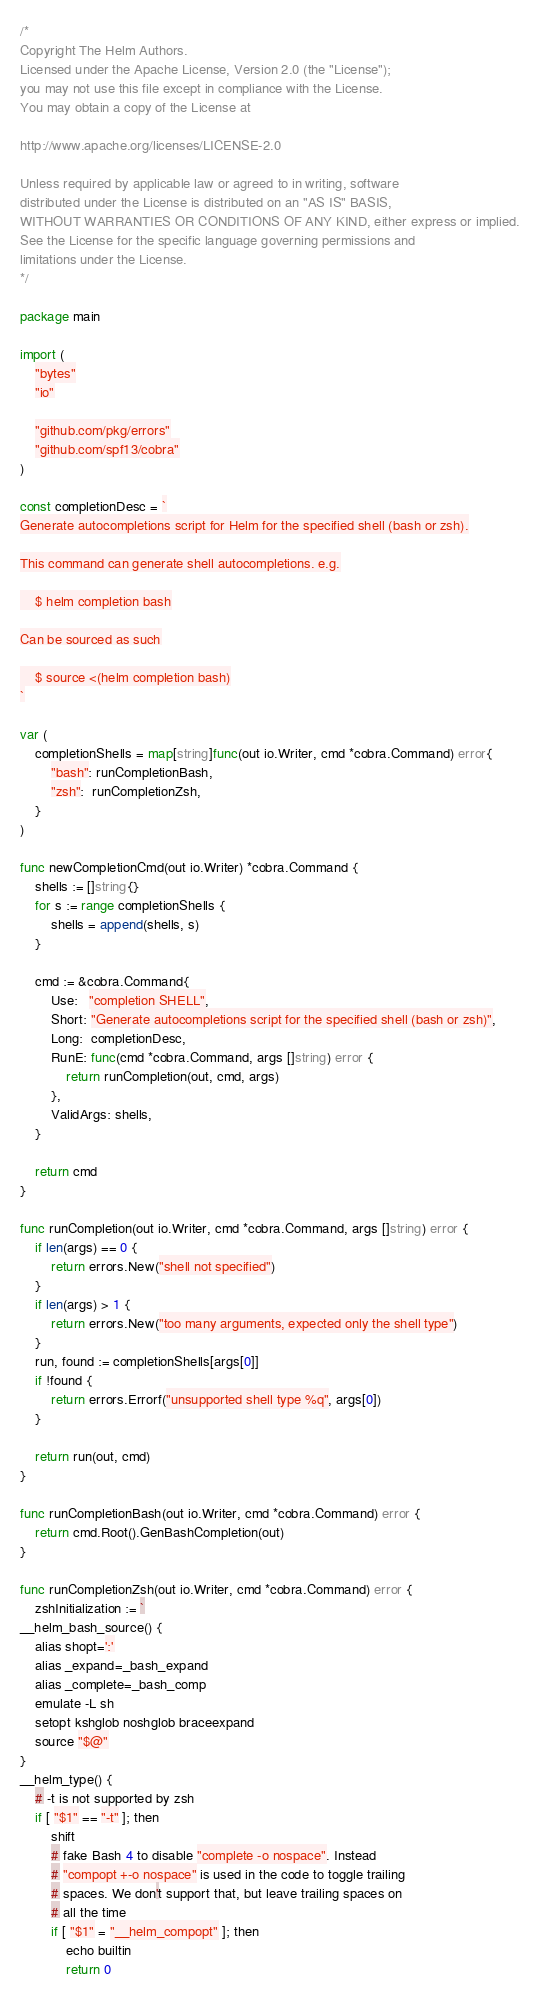Convert code to text. <code><loc_0><loc_0><loc_500><loc_500><_Go_>/*
Copyright The Helm Authors.
Licensed under the Apache License, Version 2.0 (the "License");
you may not use this file except in compliance with the License.
You may obtain a copy of the License at

http://www.apache.org/licenses/LICENSE-2.0

Unless required by applicable law or agreed to in writing, software
distributed under the License is distributed on an "AS IS" BASIS,
WITHOUT WARRANTIES OR CONDITIONS OF ANY KIND, either express or implied.
See the License for the specific language governing permissions and
limitations under the License.
*/

package main

import (
	"bytes"
	"io"

	"github.com/pkg/errors"
	"github.com/spf13/cobra"
)

const completionDesc = `
Generate autocompletions script for Helm for the specified shell (bash or zsh).

This command can generate shell autocompletions. e.g.

	$ helm completion bash

Can be sourced as such

	$ source <(helm completion bash)
`

var (
	completionShells = map[string]func(out io.Writer, cmd *cobra.Command) error{
		"bash": runCompletionBash,
		"zsh":  runCompletionZsh,
	}
)

func newCompletionCmd(out io.Writer) *cobra.Command {
	shells := []string{}
	for s := range completionShells {
		shells = append(shells, s)
	}

	cmd := &cobra.Command{
		Use:   "completion SHELL",
		Short: "Generate autocompletions script for the specified shell (bash or zsh)",
		Long:  completionDesc,
		RunE: func(cmd *cobra.Command, args []string) error {
			return runCompletion(out, cmd, args)
		},
		ValidArgs: shells,
	}

	return cmd
}

func runCompletion(out io.Writer, cmd *cobra.Command, args []string) error {
	if len(args) == 0 {
		return errors.New("shell not specified")
	}
	if len(args) > 1 {
		return errors.New("too many arguments, expected only the shell type")
	}
	run, found := completionShells[args[0]]
	if !found {
		return errors.Errorf("unsupported shell type %q", args[0])
	}

	return run(out, cmd)
}

func runCompletionBash(out io.Writer, cmd *cobra.Command) error {
	return cmd.Root().GenBashCompletion(out)
}

func runCompletionZsh(out io.Writer, cmd *cobra.Command) error {
	zshInitialization := `
__helm_bash_source() {
	alias shopt=':'
	alias _expand=_bash_expand
	alias _complete=_bash_comp
	emulate -L sh
	setopt kshglob noshglob braceexpand
	source "$@"
}
__helm_type() {
	# -t is not supported by zsh
	if [ "$1" == "-t" ]; then
		shift
		# fake Bash 4 to disable "complete -o nospace". Instead
		# "compopt +-o nospace" is used in the code to toggle trailing
		# spaces. We don't support that, but leave trailing spaces on
		# all the time
		if [ "$1" = "__helm_compopt" ]; then
			echo builtin
			return 0</code> 